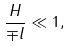Convert formula to latex. <formula><loc_0><loc_0><loc_500><loc_500>\frac { H } { \mp l } \ll 1 ,</formula> 